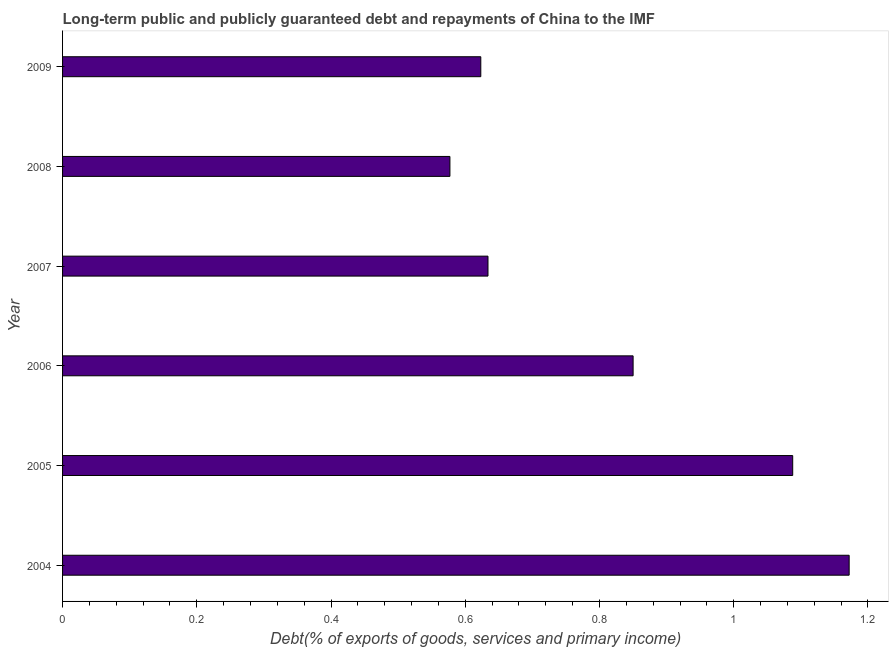Does the graph contain any zero values?
Your response must be concise. No. Does the graph contain grids?
Give a very brief answer. No. What is the title of the graph?
Your answer should be very brief. Long-term public and publicly guaranteed debt and repayments of China to the IMF. What is the label or title of the X-axis?
Offer a very short reply. Debt(% of exports of goods, services and primary income). What is the label or title of the Y-axis?
Provide a short and direct response. Year. What is the debt service in 2004?
Your response must be concise. 1.17. Across all years, what is the maximum debt service?
Your response must be concise. 1.17. Across all years, what is the minimum debt service?
Offer a terse response. 0.58. In which year was the debt service maximum?
Make the answer very short. 2004. What is the sum of the debt service?
Ensure brevity in your answer.  4.94. What is the difference between the debt service in 2006 and 2009?
Offer a very short reply. 0.23. What is the average debt service per year?
Give a very brief answer. 0.82. What is the median debt service?
Provide a succinct answer. 0.74. What is the ratio of the debt service in 2006 to that in 2007?
Offer a very short reply. 1.34. Is the debt service in 2005 less than that in 2006?
Your answer should be compact. No. Is the difference between the debt service in 2004 and 2008 greater than the difference between any two years?
Your answer should be very brief. Yes. What is the difference between the highest and the second highest debt service?
Make the answer very short. 0.08. What is the difference between the highest and the lowest debt service?
Provide a succinct answer. 0.59. How many bars are there?
Offer a terse response. 6. Are the values on the major ticks of X-axis written in scientific E-notation?
Provide a succinct answer. No. What is the Debt(% of exports of goods, services and primary income) of 2004?
Give a very brief answer. 1.17. What is the Debt(% of exports of goods, services and primary income) of 2005?
Ensure brevity in your answer.  1.09. What is the Debt(% of exports of goods, services and primary income) of 2006?
Offer a terse response. 0.85. What is the Debt(% of exports of goods, services and primary income) of 2007?
Make the answer very short. 0.63. What is the Debt(% of exports of goods, services and primary income) in 2008?
Provide a short and direct response. 0.58. What is the Debt(% of exports of goods, services and primary income) in 2009?
Offer a very short reply. 0.62. What is the difference between the Debt(% of exports of goods, services and primary income) in 2004 and 2005?
Your answer should be compact. 0.08. What is the difference between the Debt(% of exports of goods, services and primary income) in 2004 and 2006?
Offer a very short reply. 0.32. What is the difference between the Debt(% of exports of goods, services and primary income) in 2004 and 2007?
Make the answer very short. 0.54. What is the difference between the Debt(% of exports of goods, services and primary income) in 2004 and 2008?
Your answer should be compact. 0.59. What is the difference between the Debt(% of exports of goods, services and primary income) in 2004 and 2009?
Give a very brief answer. 0.55. What is the difference between the Debt(% of exports of goods, services and primary income) in 2005 and 2006?
Your answer should be very brief. 0.24. What is the difference between the Debt(% of exports of goods, services and primary income) in 2005 and 2007?
Your answer should be compact. 0.45. What is the difference between the Debt(% of exports of goods, services and primary income) in 2005 and 2008?
Make the answer very short. 0.51. What is the difference between the Debt(% of exports of goods, services and primary income) in 2005 and 2009?
Offer a very short reply. 0.46. What is the difference between the Debt(% of exports of goods, services and primary income) in 2006 and 2007?
Provide a short and direct response. 0.22. What is the difference between the Debt(% of exports of goods, services and primary income) in 2006 and 2008?
Your answer should be very brief. 0.27. What is the difference between the Debt(% of exports of goods, services and primary income) in 2006 and 2009?
Give a very brief answer. 0.23. What is the difference between the Debt(% of exports of goods, services and primary income) in 2007 and 2008?
Make the answer very short. 0.06. What is the difference between the Debt(% of exports of goods, services and primary income) in 2007 and 2009?
Your answer should be compact. 0.01. What is the difference between the Debt(% of exports of goods, services and primary income) in 2008 and 2009?
Provide a succinct answer. -0.05. What is the ratio of the Debt(% of exports of goods, services and primary income) in 2004 to that in 2005?
Offer a very short reply. 1.08. What is the ratio of the Debt(% of exports of goods, services and primary income) in 2004 to that in 2006?
Your response must be concise. 1.38. What is the ratio of the Debt(% of exports of goods, services and primary income) in 2004 to that in 2007?
Provide a short and direct response. 1.85. What is the ratio of the Debt(% of exports of goods, services and primary income) in 2004 to that in 2008?
Provide a succinct answer. 2.03. What is the ratio of the Debt(% of exports of goods, services and primary income) in 2004 to that in 2009?
Make the answer very short. 1.88. What is the ratio of the Debt(% of exports of goods, services and primary income) in 2005 to that in 2006?
Your answer should be very brief. 1.28. What is the ratio of the Debt(% of exports of goods, services and primary income) in 2005 to that in 2007?
Offer a terse response. 1.72. What is the ratio of the Debt(% of exports of goods, services and primary income) in 2005 to that in 2008?
Give a very brief answer. 1.89. What is the ratio of the Debt(% of exports of goods, services and primary income) in 2005 to that in 2009?
Keep it short and to the point. 1.75. What is the ratio of the Debt(% of exports of goods, services and primary income) in 2006 to that in 2007?
Keep it short and to the point. 1.34. What is the ratio of the Debt(% of exports of goods, services and primary income) in 2006 to that in 2008?
Make the answer very short. 1.47. What is the ratio of the Debt(% of exports of goods, services and primary income) in 2006 to that in 2009?
Your answer should be very brief. 1.36. What is the ratio of the Debt(% of exports of goods, services and primary income) in 2007 to that in 2008?
Offer a terse response. 1.1. What is the ratio of the Debt(% of exports of goods, services and primary income) in 2007 to that in 2009?
Ensure brevity in your answer.  1.02. What is the ratio of the Debt(% of exports of goods, services and primary income) in 2008 to that in 2009?
Keep it short and to the point. 0.93. 